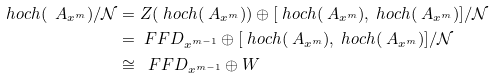<formula> <loc_0><loc_0><loc_500><loc_500>\ h o c h ( \ A _ { x ^ { m } } ) / \mathcal { N } & = Z ( \ h o c h ( \ A _ { x ^ { m } } ) ) \oplus [ \ h o c h ( \ A _ { x ^ { m } } ) , \ h o c h ( \ A _ { x ^ { m } } ) ] / \mathcal { N } \\ & = \ F F D _ { x ^ { m - 1 } } \oplus [ \ h o c h ( \ A _ { x ^ { m } } ) , \ h o c h ( \ A _ { x ^ { m } } ) ] / \mathcal { N } \\ & \cong \ \ F F D _ { x ^ { m - 1 } } \oplus W</formula> 